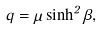<formula> <loc_0><loc_0><loc_500><loc_500>q = \mu \sinh ^ { 2 } \beta ,</formula> 